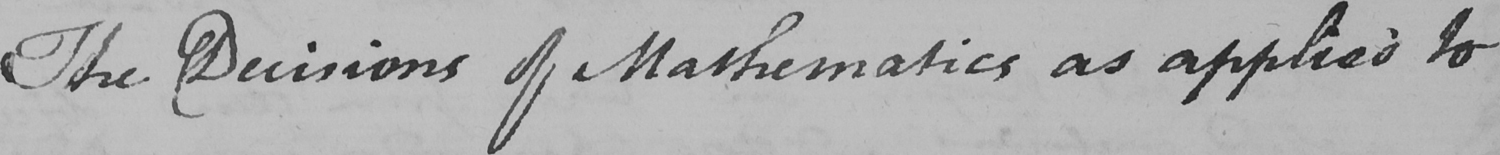Can you tell me what this handwritten text says? The Decisions of Mathematics as applied to 